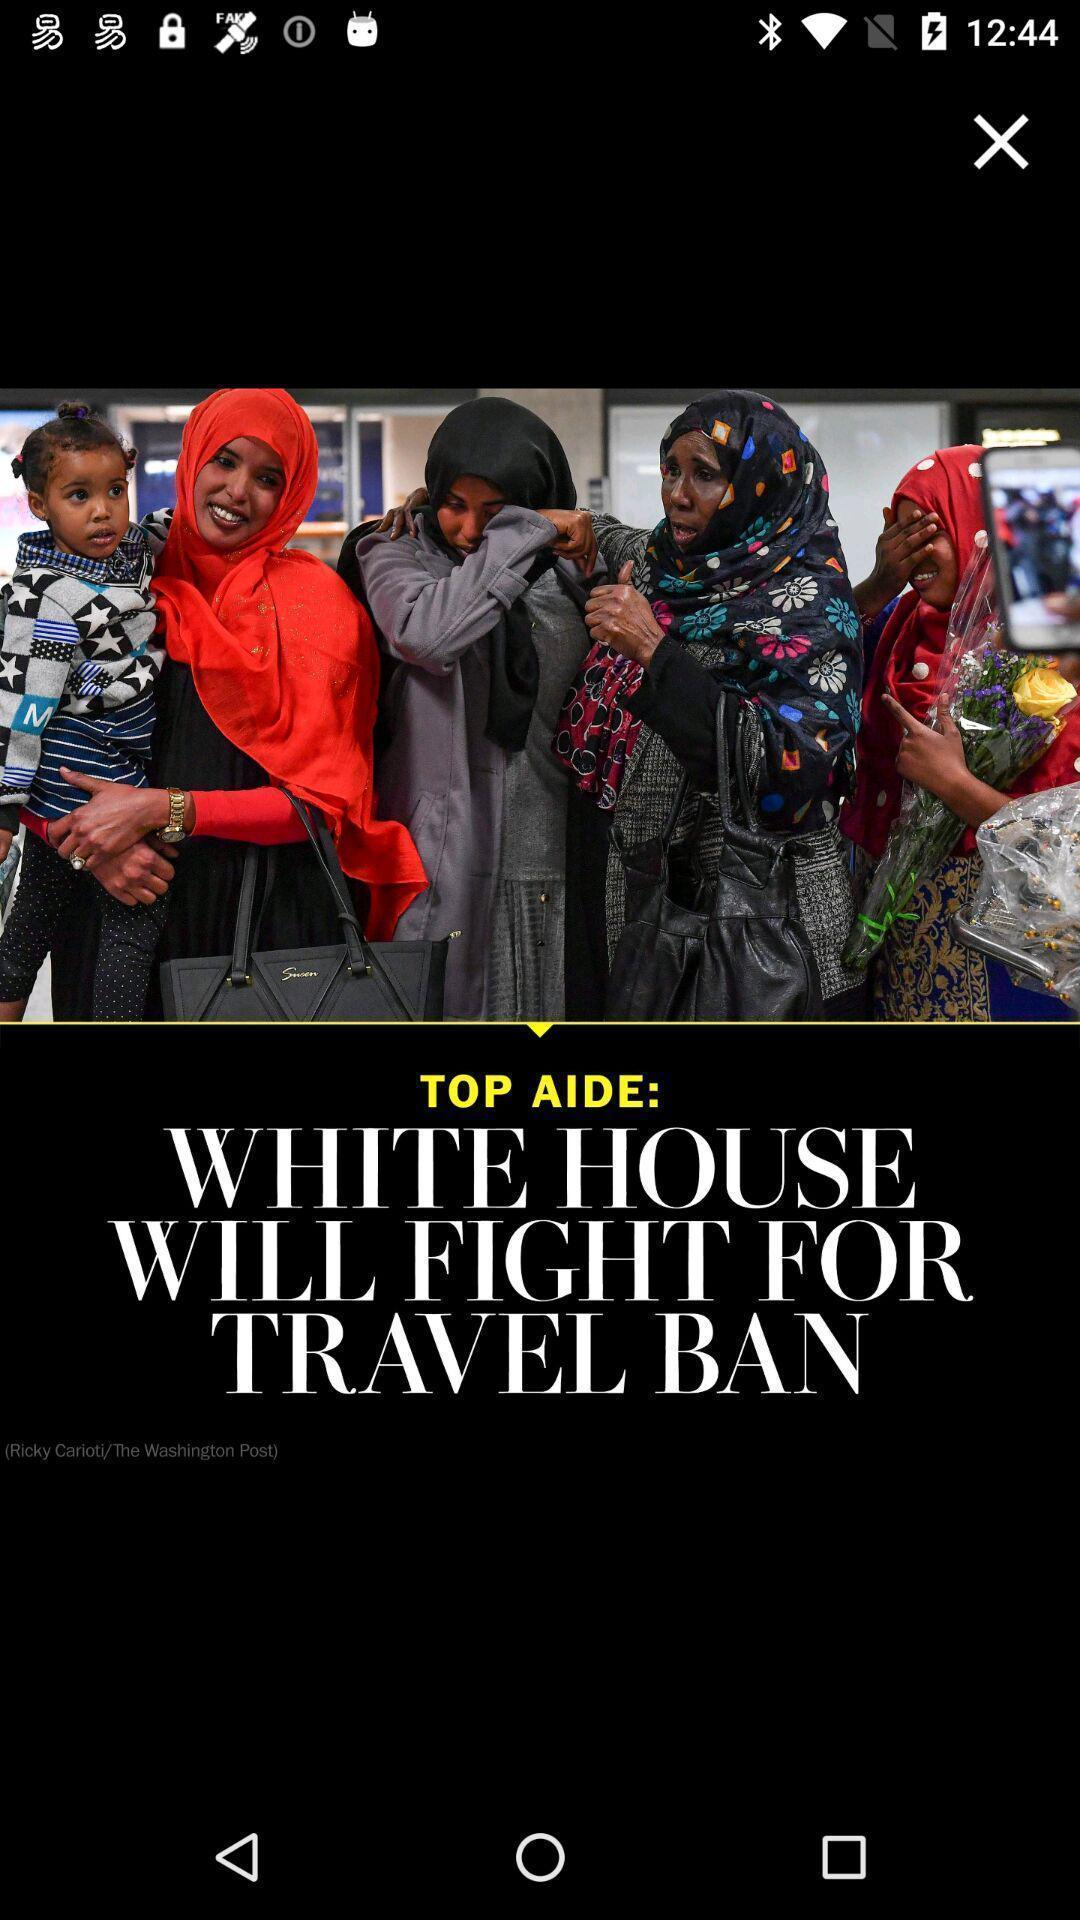Give me a narrative description of this picture. Screen showing post /news. 